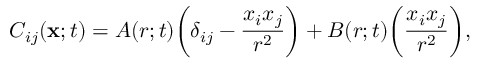<formula> <loc_0><loc_0><loc_500><loc_500>C _ { i j } ( { x } ; t ) = A ( r ; t ) \left ( \delta _ { i j } - \frac { x _ { i } x _ { j } } { r ^ { 2 } } \right ) + B ( r ; t ) \left ( \frac { x _ { i } x _ { j } } { r ^ { 2 } } \right ) ,</formula> 